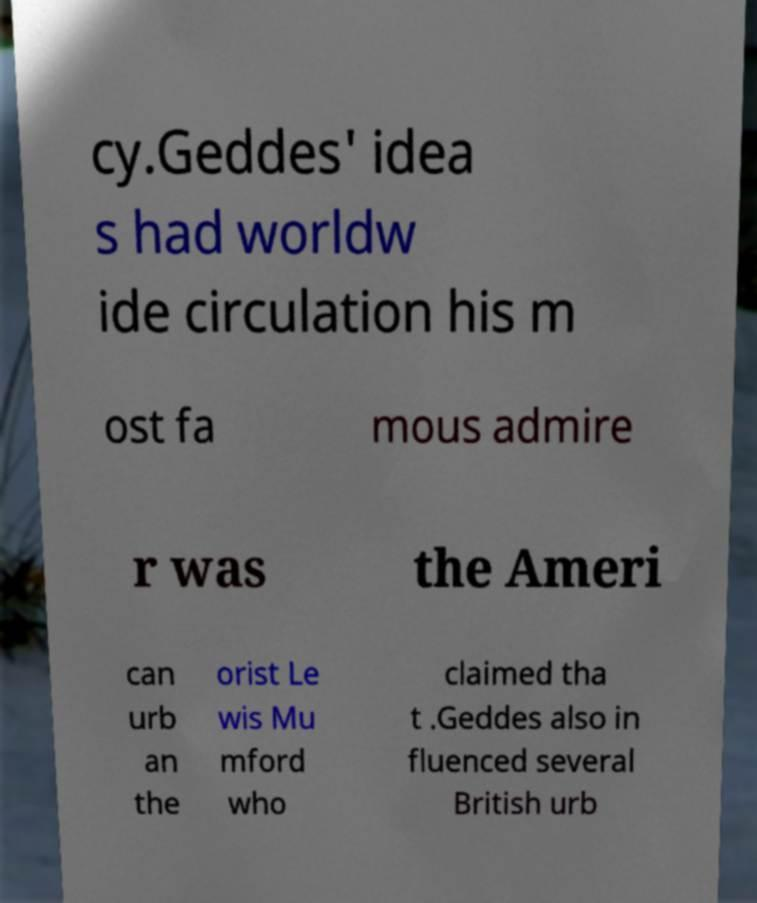Please identify and transcribe the text found in this image. cy.Geddes' idea s had worldw ide circulation his m ost fa mous admire r was the Ameri can urb an the orist Le wis Mu mford who claimed tha t .Geddes also in fluenced several British urb 